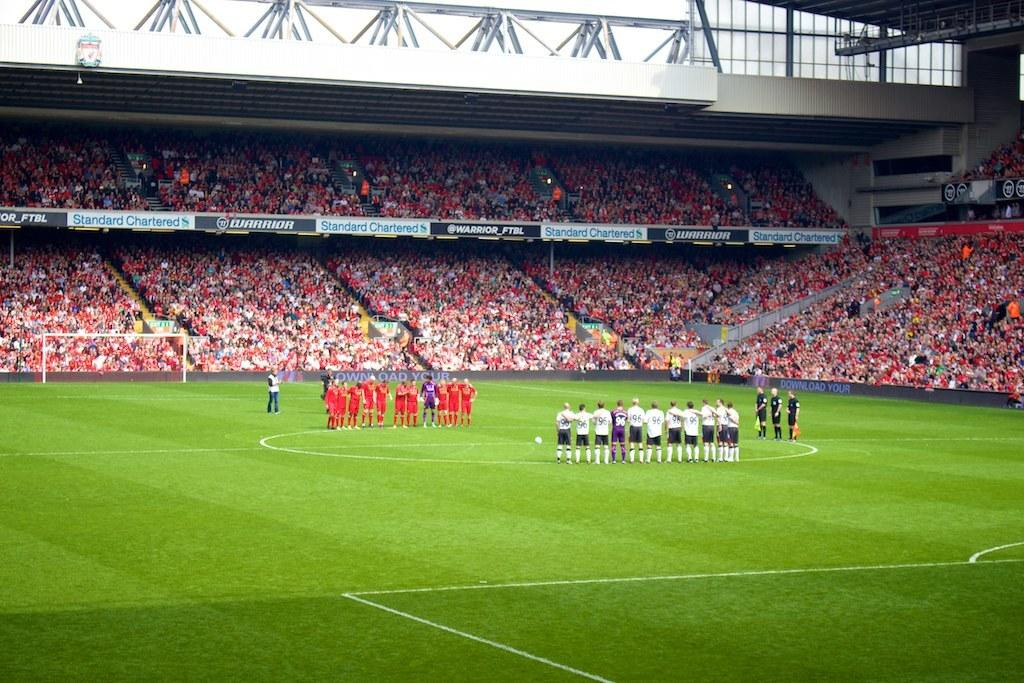<image>
Share a concise interpretation of the image provided. Two teams of soccer players stand on the field, an advertisement reads Warrior_FTBL. 